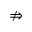<formula> <loc_0><loc_0><loc_500><loc_500>\ n R i g h t a r r o w</formula> 